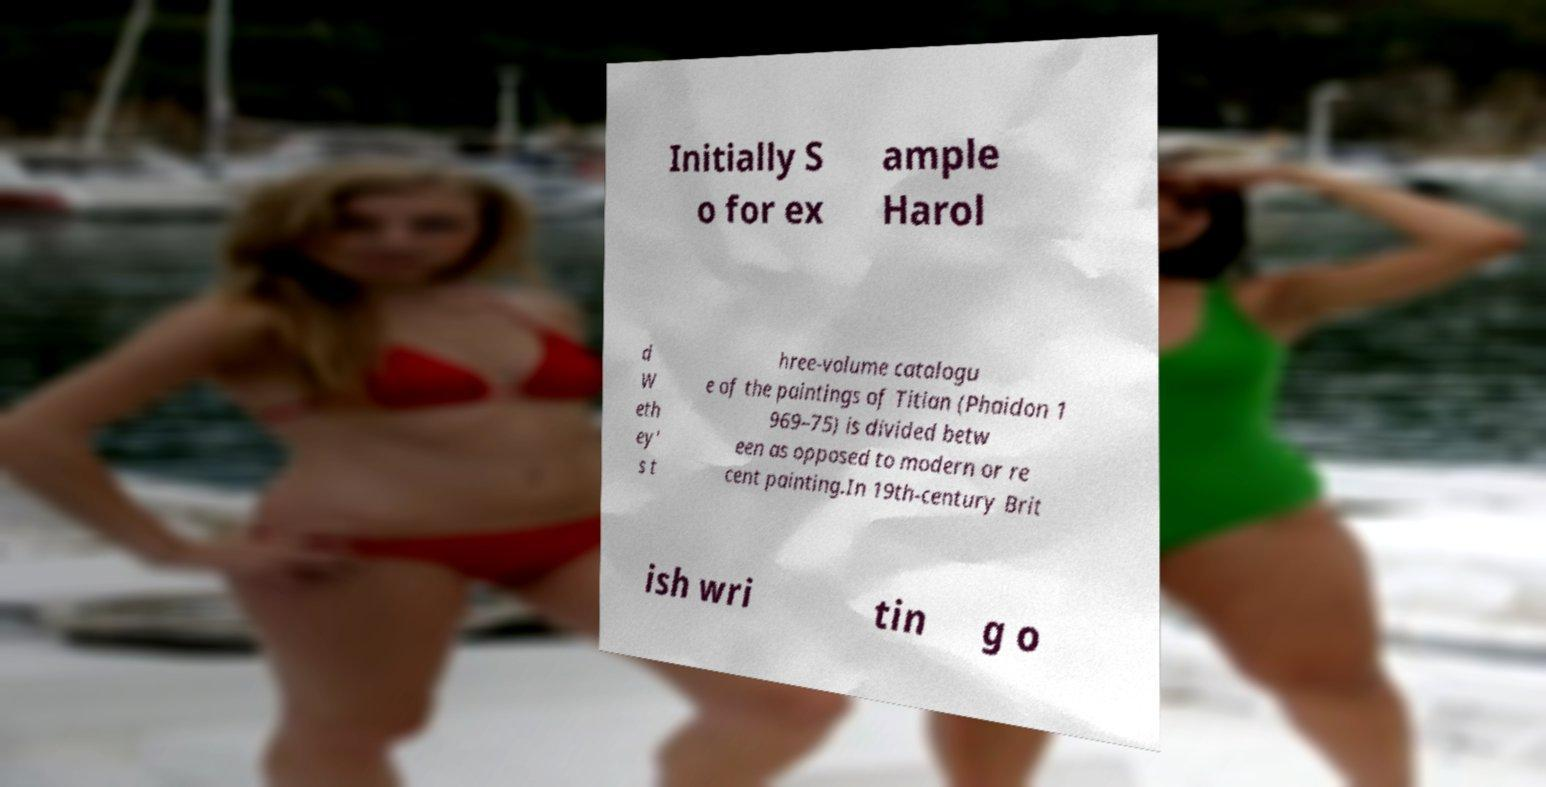What messages or text are displayed in this image? I need them in a readable, typed format. Initially S o for ex ample Harol d W eth ey' s t hree-volume catalogu e of the paintings of Titian (Phaidon 1 969–75) is divided betw een as opposed to modern or re cent painting.In 19th-century Brit ish wri tin g o 